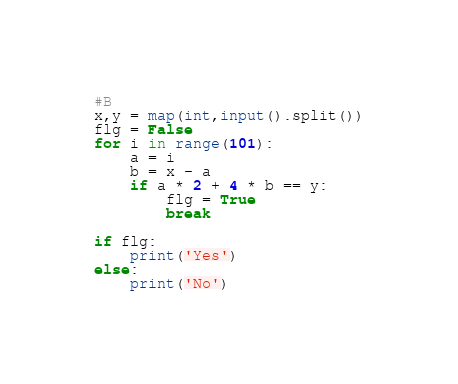Convert code to text. <code><loc_0><loc_0><loc_500><loc_500><_Python_>#B
x,y = map(int,input().split())
flg = False
for i in range(101):
    a = i
    b = x - a
    if a * 2 + 4 * b == y:
        flg = True
        break
        
if flg:
    print('Yes')
else:
    print('No')</code> 